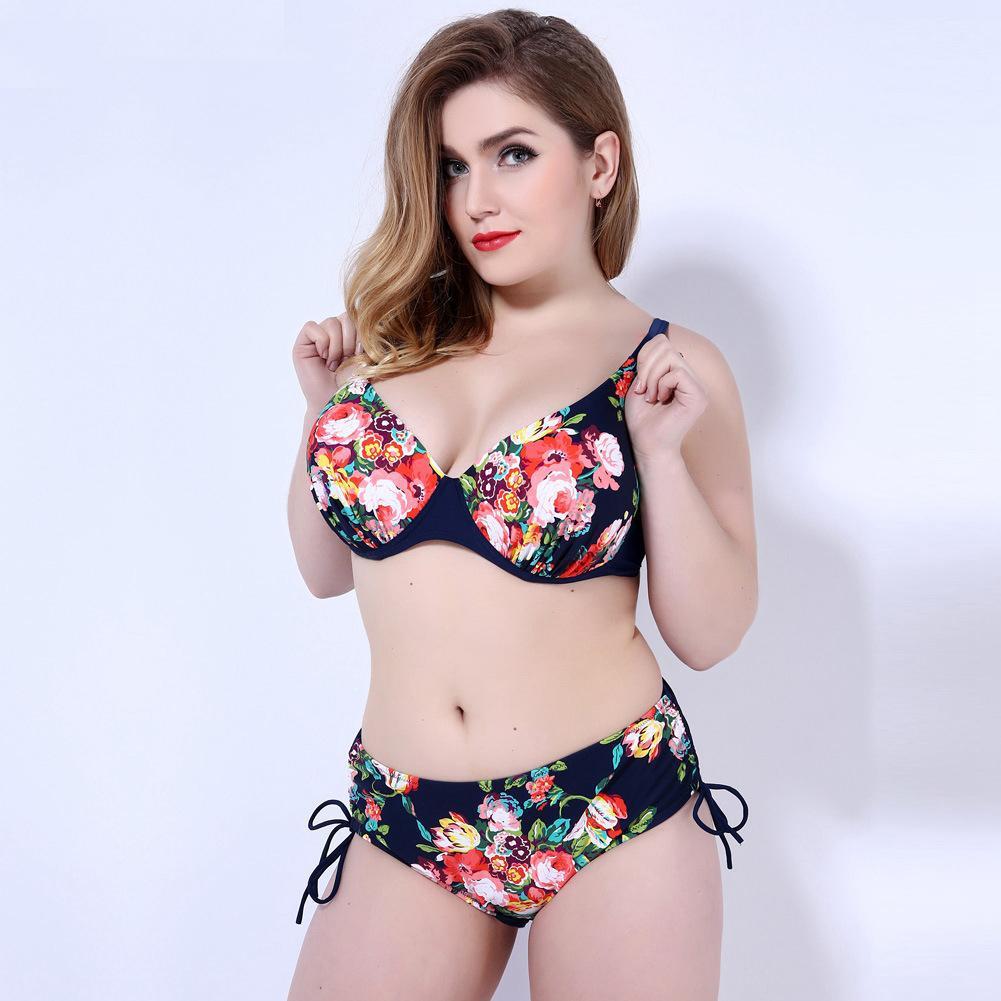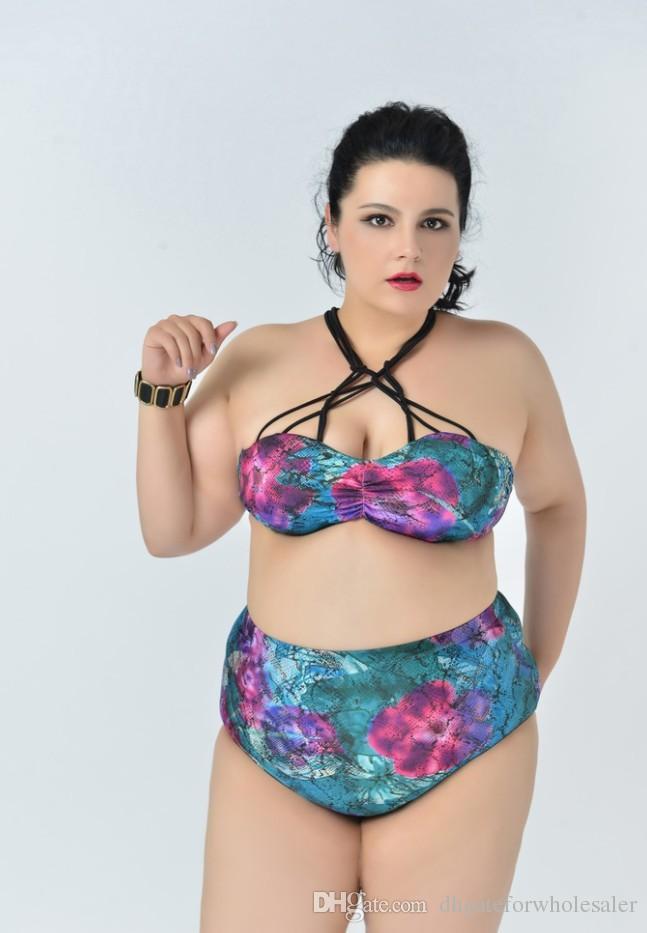The first image is the image on the left, the second image is the image on the right. Evaluate the accuracy of this statement regarding the images: "At least one image features a model in matching-colored solid aqua bikini.". Is it true? Answer yes or no. No. The first image is the image on the left, the second image is the image on the right. Evaluate the accuracy of this statement regarding the images: "There are two bikinis that are primarily blue in color". Is it true? Answer yes or no. No. 